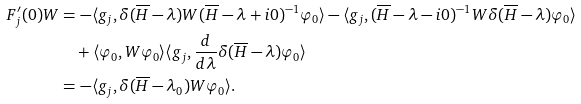Convert formula to latex. <formula><loc_0><loc_0><loc_500><loc_500>F _ { j } ^ { \prime } ( 0 ) W & = - \langle g _ { j } , \delta ( \overline { H } - \lambda ) W ( \overline { H } - \lambda + i 0 ) ^ { - 1 } \varphi _ { 0 } \rangle - \langle g _ { j } , ( \overline { H } - \lambda - i 0 ) ^ { - 1 } W \delta ( \overline { H } - \lambda ) \varphi _ { 0 } \rangle \\ & \quad + \langle \varphi _ { 0 } , W \varphi _ { 0 } \rangle \langle g _ { j } , \frac { d } { d \lambda } \delta ( \overline { H } - \lambda ) \varphi _ { 0 } \rangle \\ & = - \langle g _ { j } , \delta ( \overline { H } - \lambda _ { 0 } ) W \varphi _ { 0 } \rangle .</formula> 